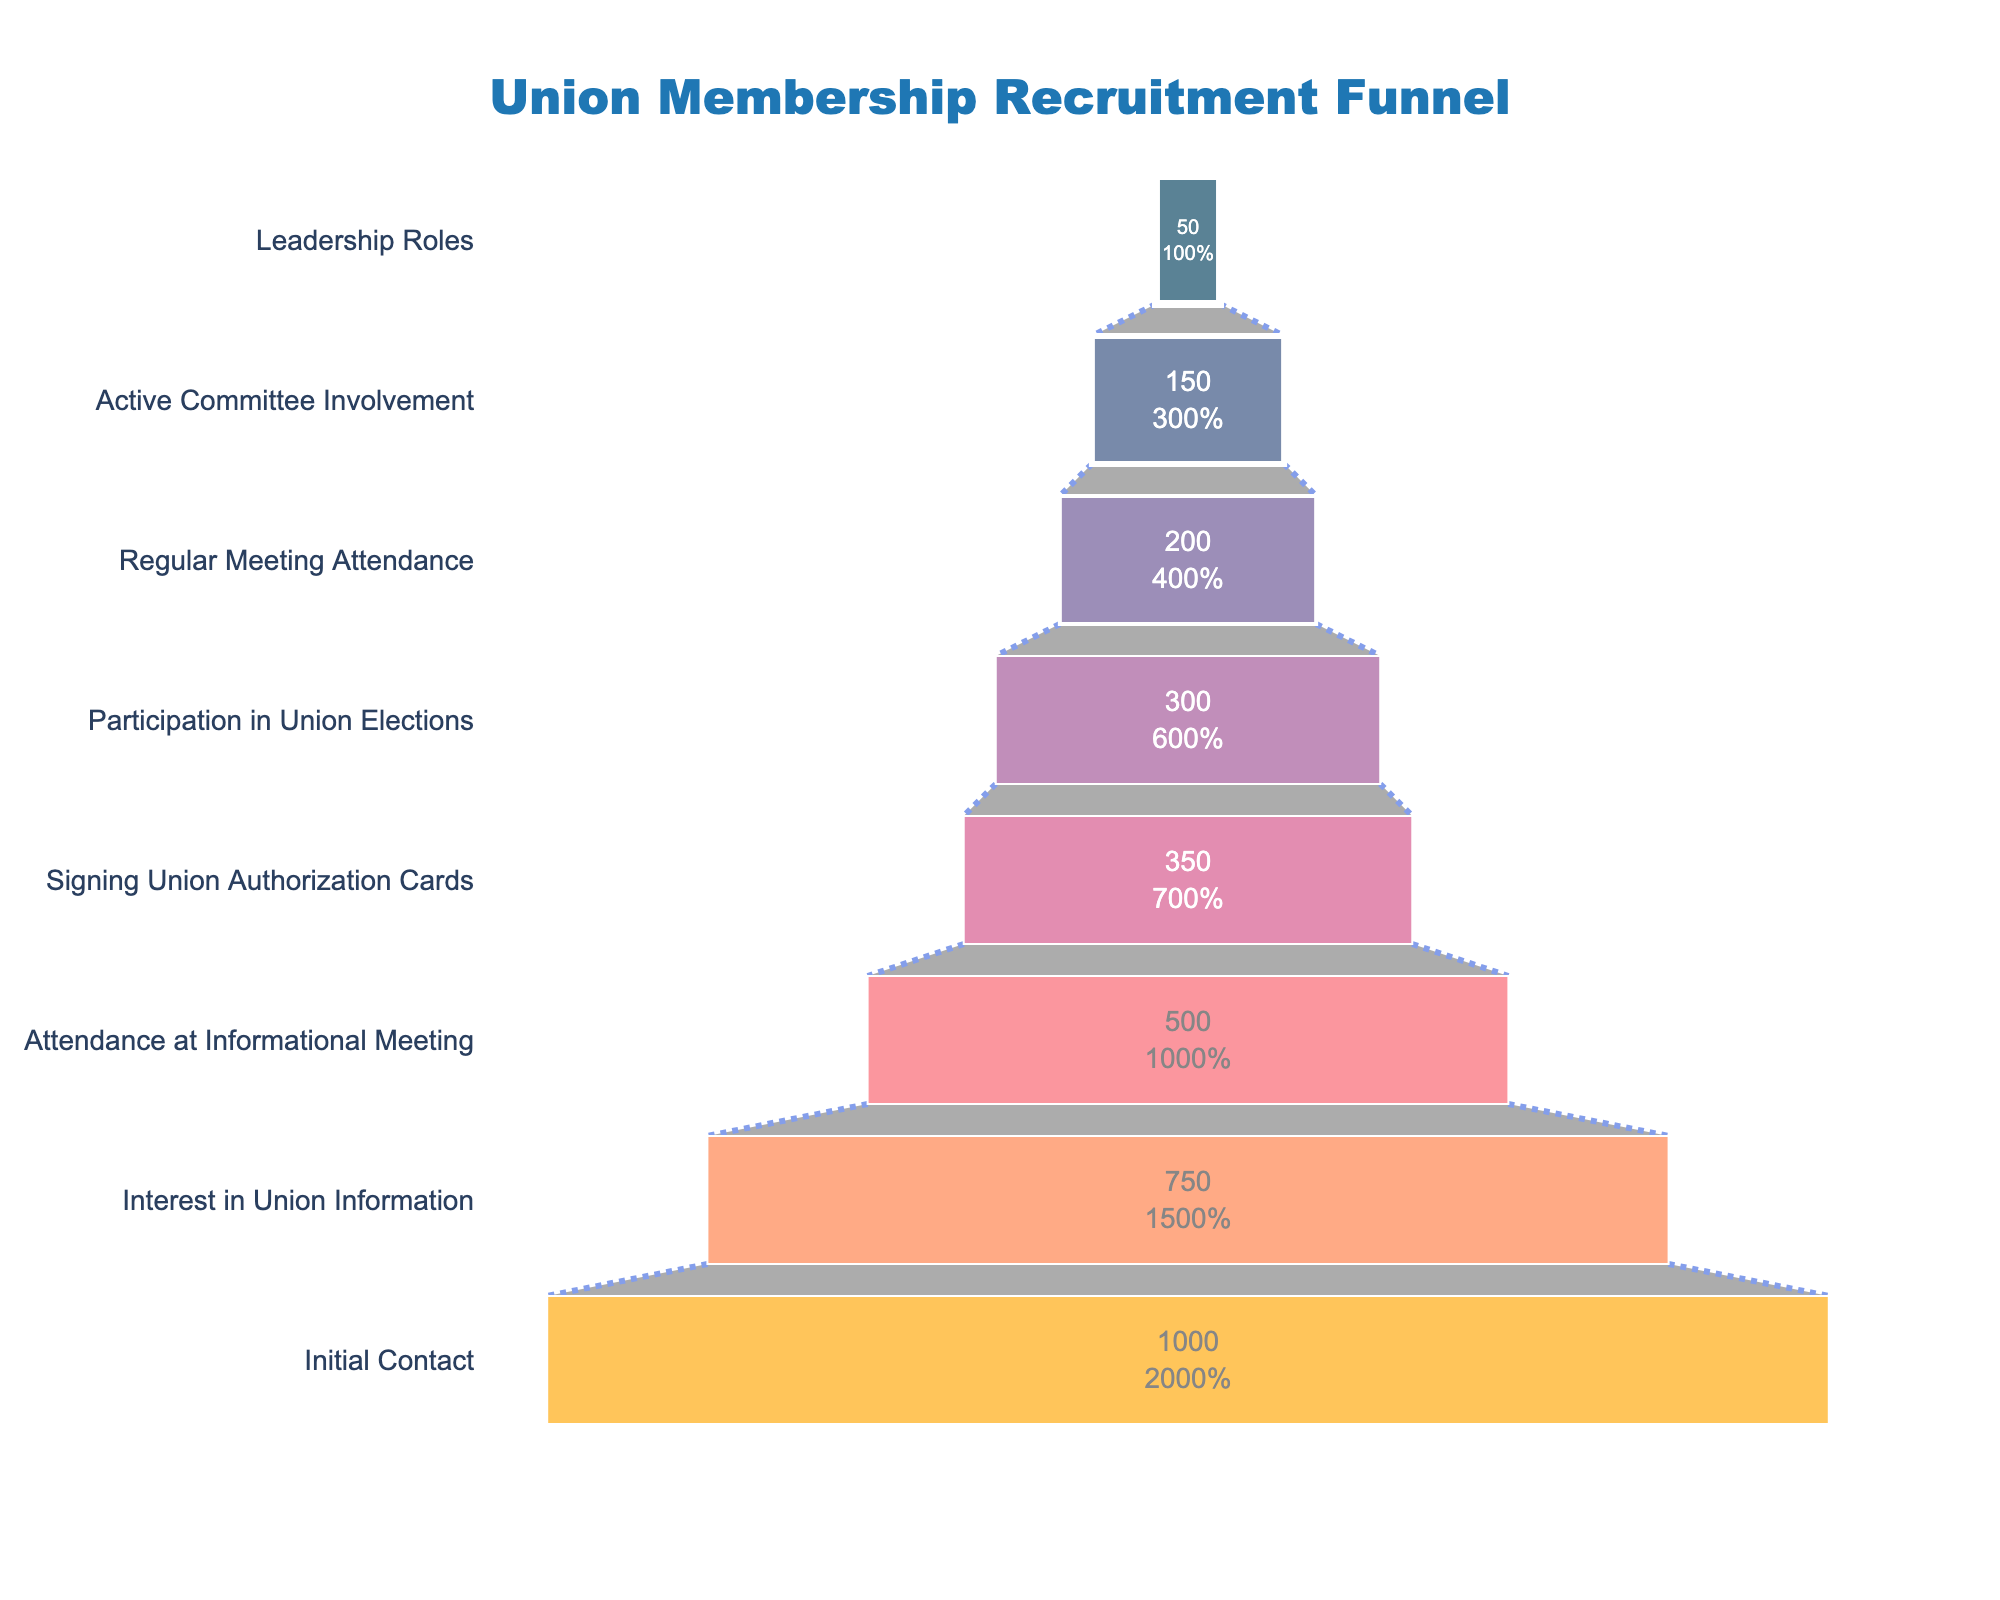What is the title of the figure? The title is prominently displayed at the top center of the chart.
Answer: Union Membership Recruitment Funnel How many stages are there in the recruitment funnel? Count the number of stages listed along the y-axis.
Answer: 8 How many people show interest in union information? Look at the corresponding stage "Interest in Union Information" and the value associated with it.
Answer: 750 What is the difference in the number of people between the Initial Contact stage and the Interest in Union Information stage? Subtract the number of people at "Interest in Union Information" from the number of people at "Initial Contact": 1000 - 750.
Answer: 250 What percentage of the initial contact group signs union authorization cards? Divide the number of people who signed union authorization cards by the initial contact number and multiply by 100 to get the percentage: (350 / 1000) * 100.
Answer: 35% How many more people attend informational meetings compared to those who sign union authorization cards? Subtract the number of people at "Signing Union Authorization Cards" from the number of people at "Attendance at Informational Meeting": 500 - 350.
Answer: 150 Compare the number of people involved in leadership roles to those with active committee involvement. What is the difference? Subtract the number of people in "Leadership Roles" from those in "Active Committee Involvement": 150 - 50.
Answer: 100 Which stage has the highest drop-off in the number of people from one stage to the next? Calculate the difference between each consecutive stage and identify the largest drop. 
- Initial to Interest: 250
- Interest to Attendance: 250
- Attendance to Signing: 150
- Signing to Participation: 50
- Participation to Regular: 100
- Regular to Active: 50
- Active to Leadership: 100
The highest drop-off occurs between Initial Contact to Interest in Union Information and Interest in Union Information to Attendance at Informational Meeting which are both 250.
Answer: Initial Contact to Interest in Union Information and Interest in Union Information to Attendance at Informational Meeting (250 each) What percentage of people attending informational meetings continue to sign union authorization cards? Divide the number of people who signed union authorization cards by those who attended informational meetings and multiply by 100: (350 / 500) * 100.
Answer: 70% What is the ratio of participants in union elections to those in leadership roles? Divide the number of people in "Participation in Union Elections" by the number of people in "Leadership Roles": 300 / 50.
Answer: 6:1 